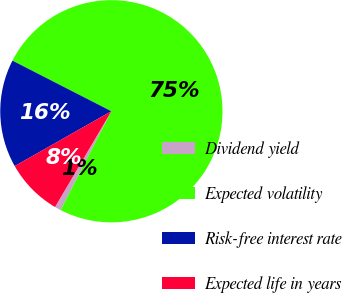Convert chart. <chart><loc_0><loc_0><loc_500><loc_500><pie_chart><fcel>Dividend yield<fcel>Expected volatility<fcel>Risk-free interest rate<fcel>Expected life in years<nl><fcel>0.91%<fcel>75.02%<fcel>15.74%<fcel>8.33%<nl></chart> 